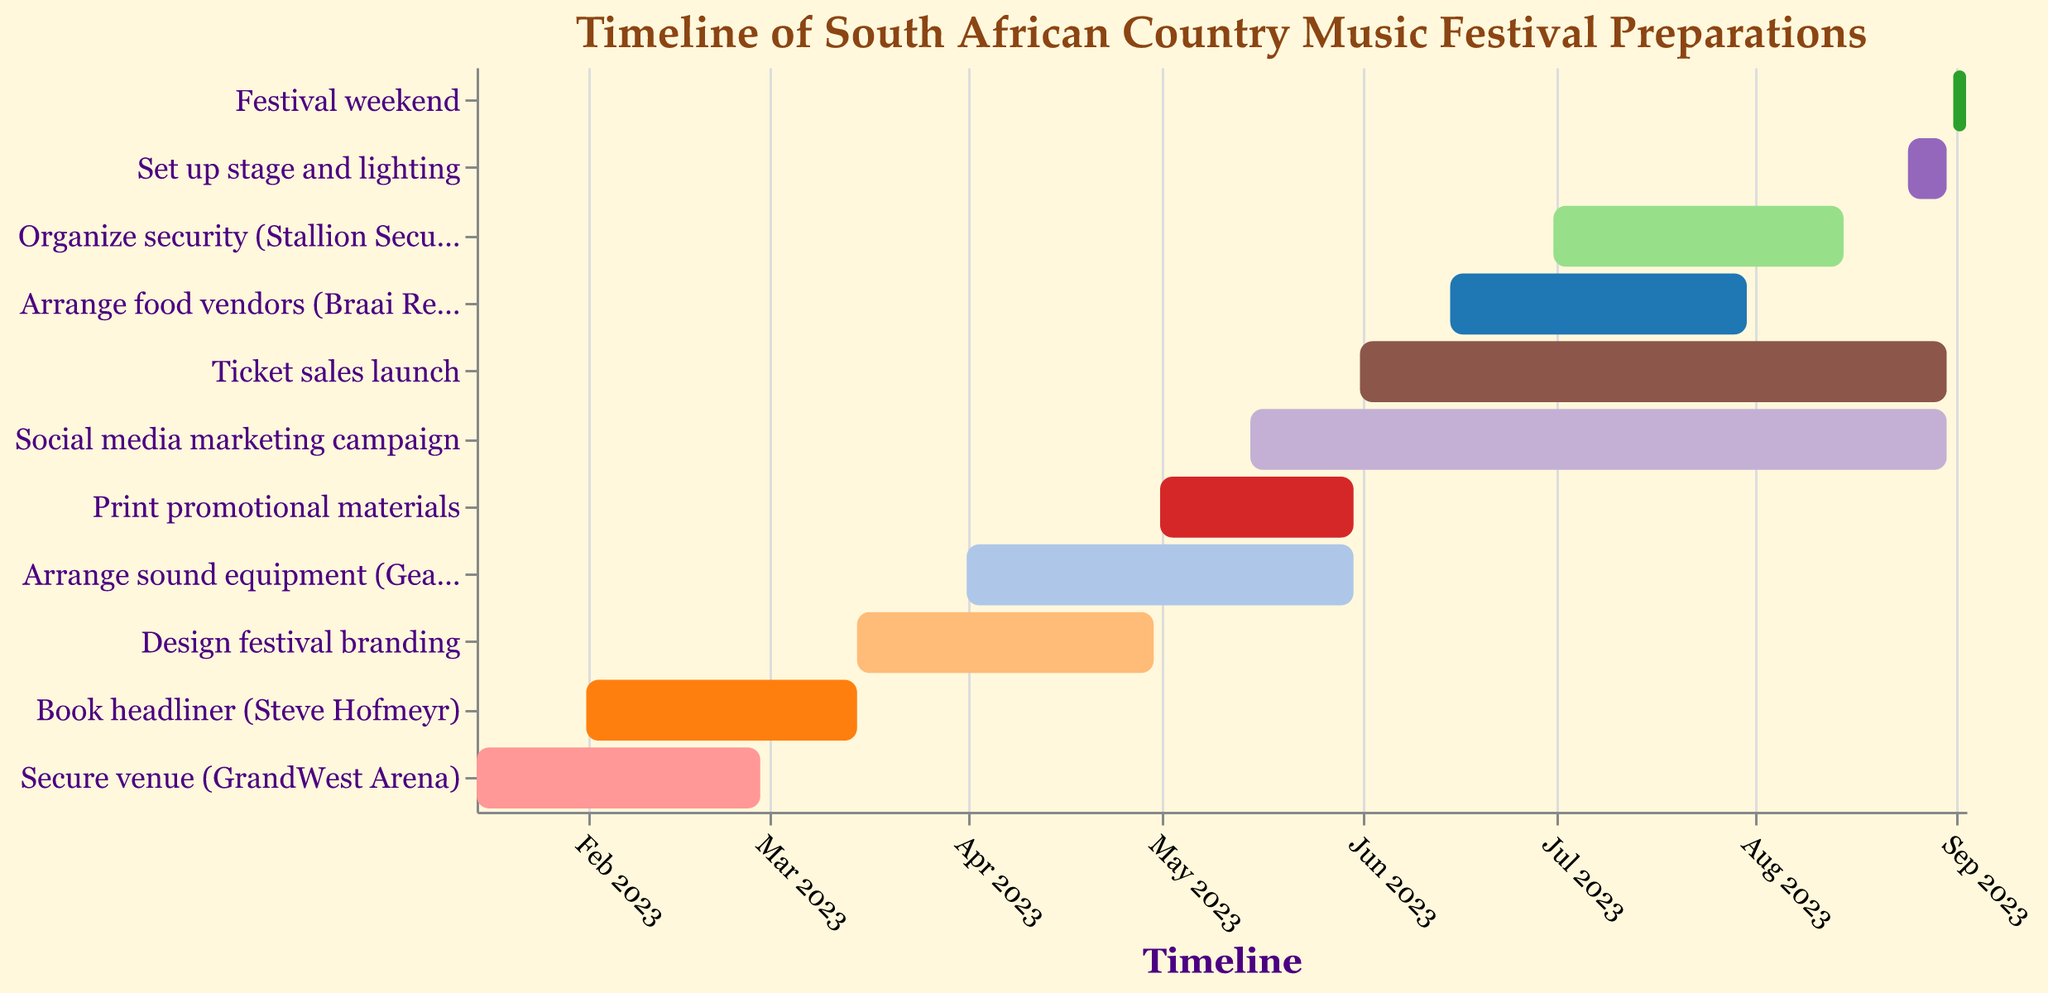What is the start date for securing the venue at GrandWest Arena? The figure shows a timeline with start and end dates for each task. Checking the bar for "Secure venue (GrandWest Arena)" and looking at its left edge, we find the start date.
Answer: 2023-01-15 When does the social media marketing campaign end? Locate the bar labeled "Social media marketing campaign" on the Gantt chart. The right edge of this bar represents the ending date.
Answer: 2023-08-31 Which tasks are scheduled to be completed by the end of February 2023? Identify tasks with end dates on or before 2023-02-28. The tasks are "Secure venue (GrandWest Arena)" ending on 2023-02-28.
Answer: Secure venue (GrandWest Arena) How long is the ticket sales launch period? Find the bar for "Ticket sales launch" and calculate the number of days between the start date (2023-06-01) and end date (2023-08-31).
Answer: 92 days Which tasks are only one-month-long? Identify bars that span exactly one month from start to end date. "Print promotional materials" fits this criterion, spanning from 2023-05-01 to 2023-05-31.
Answer: Print promotional materials When does the stage and lighting setup start, and how close is it to the festival weekend? Locate the bar for "Set up stage and lighting" and find its start date (2023-08-25). Check the proximity to the "Festival weekend" bar starting on 2023-09-01.
Answer: 2023-08-25, 7 days before Compare the duration of arranging sound equipment to organizing security. Which one takes longer? Calculate the duration of "Arrange sound equipment" (2023-04-01 to 2023-05-31) and "Organize security" (2023-07-01 to 2023-08-15). "Arrange sound equipment" spans about 2 months, while "Organize security" spans about 1.5 months.
Answer: Arrange sound equipment Which task starts immediately after securing the venue? Find the task with a start date closest to but after 2023-02-28, the end date of "Secure venue (GrandWest Arena)". The next task is "Book headliner (Steve Hofmeyr)" starting on 2023-02-01.
Answer: Book headliner (Steve Hofmeyr) How many days are there between the start of designing festival branding and the end of arranging sound equipment? Calculate the days between the start date of "Design festival branding" (2023-03-15) and the end date of "Arrange sound equipment" (2023-05-31).
Answer: 77 days 